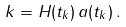<formula> <loc_0><loc_0><loc_500><loc_500>k = H ( t _ { k } ) \, a ( t _ { k } ) \, .</formula> 